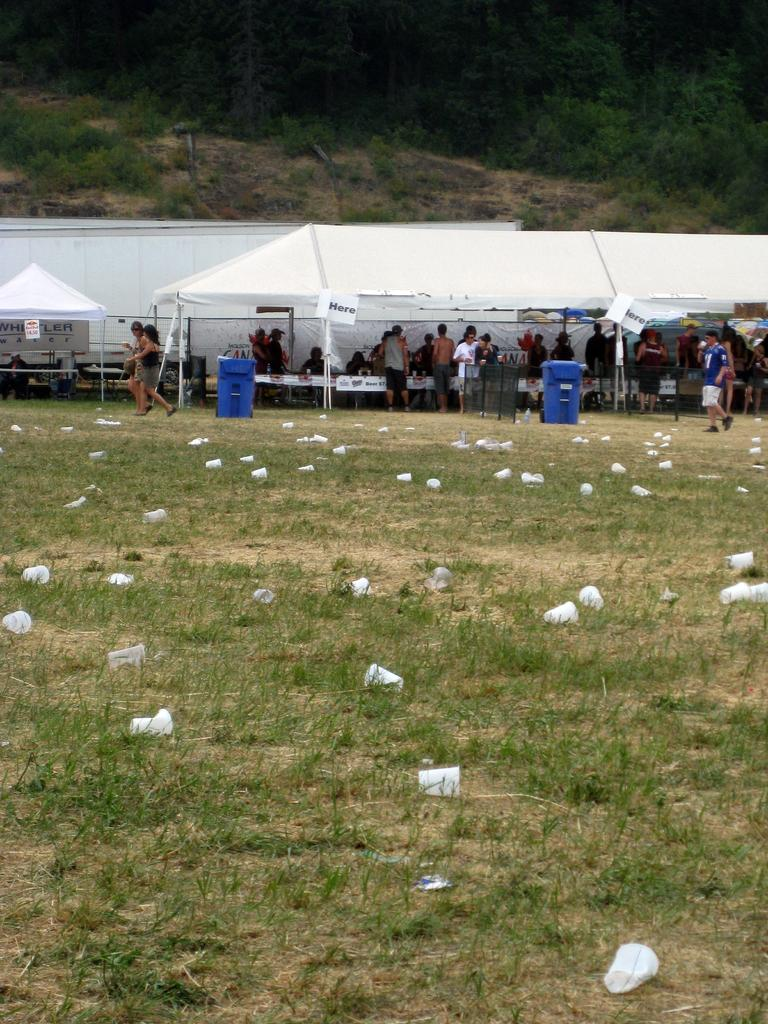How many people are in the image? The number of people in the image cannot be determined from the provided facts. What are the people doing in the image? The provided facts do not specify what the people are doing in the image. What is the surface on which the people are standing? The people are standing on the ground. What type of vegetable is being washed in the sink in the image? There is no sink or vegetable present in the image. Is there a garden visible in the image? The provided facts do not mention a garden or any vegetation in the image. 